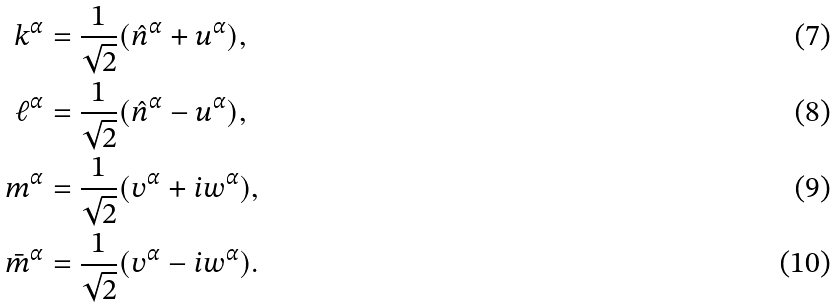Convert formula to latex. <formula><loc_0><loc_0><loc_500><loc_500>k ^ { \alpha } & = \frac { 1 } { \sqrt { 2 } } ( \hat { n } ^ { \alpha } + u ^ { \alpha } ) , \\ \ell ^ { \alpha } & = \frac { 1 } { \sqrt { 2 } } ( \hat { n } ^ { \alpha } - u ^ { \alpha } ) , \\ m ^ { \alpha } & = \frac { 1 } { \sqrt { 2 } } ( v ^ { \alpha } + i w ^ { \alpha } ) , \\ \bar { m } ^ { \alpha } & = \frac { 1 } { \sqrt { 2 } } ( v ^ { \alpha } - i w ^ { \alpha } ) .</formula> 